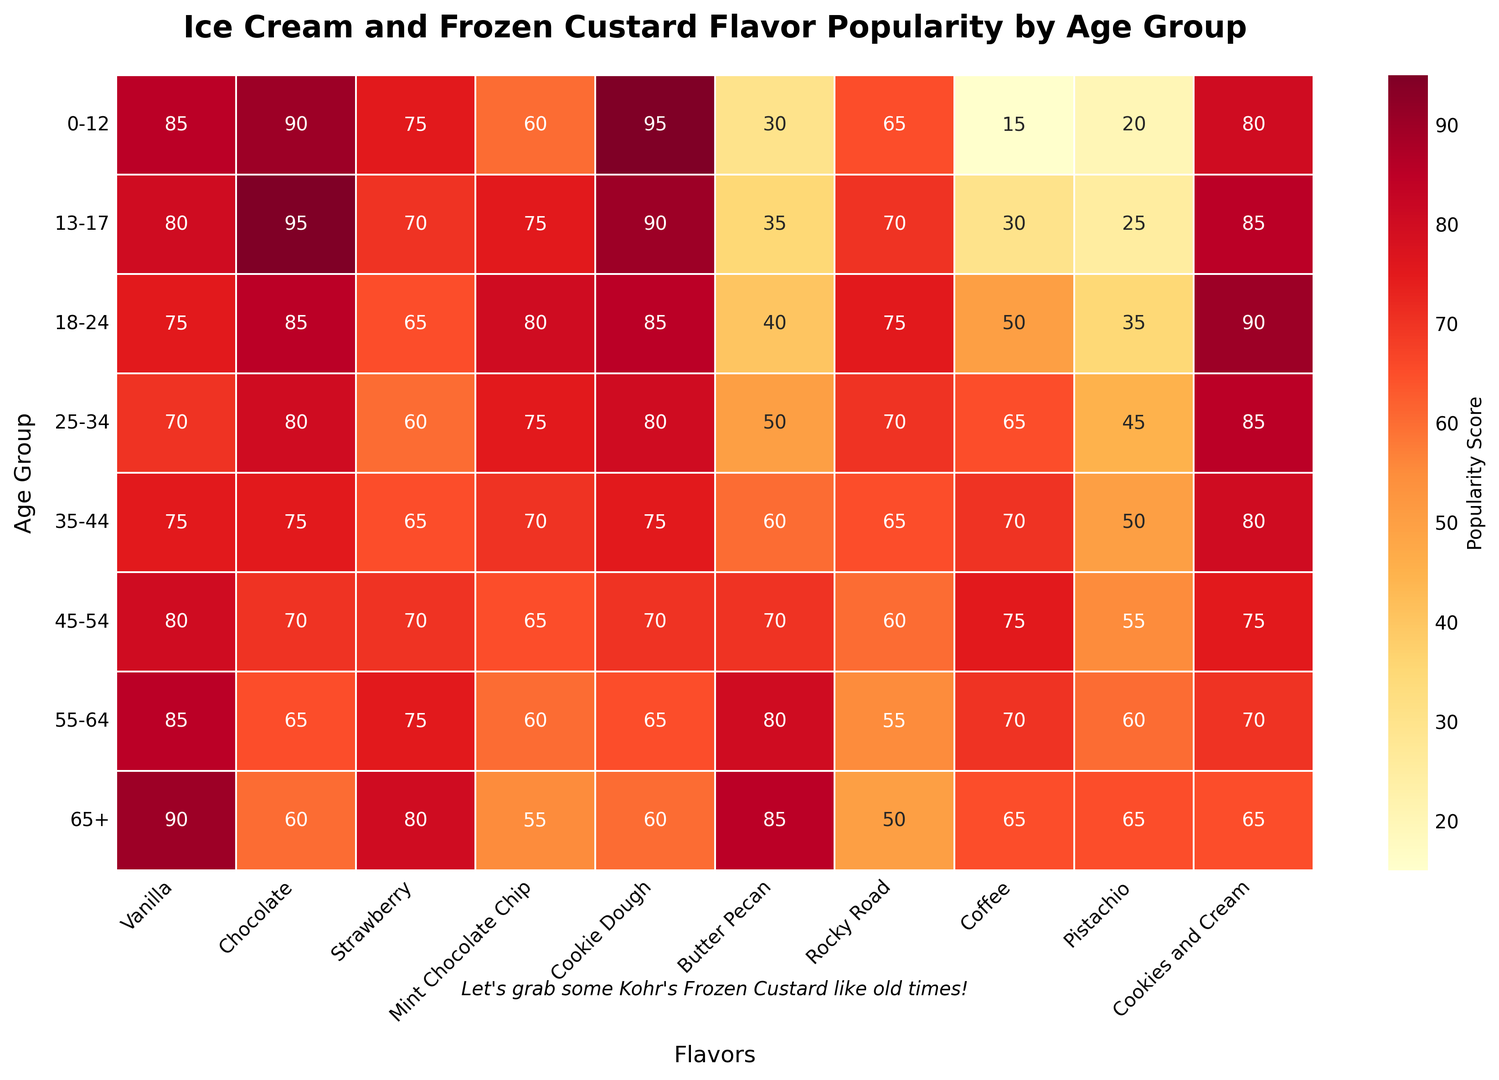Which age group has the highest popularity score for Vanilla? The colors in the heatmap and the annotations show the scores. The age group 65+ has the highest score of 90 for Vanilla.
Answer: 65+ Which flavor is most popular among teenagers aged 13-17? The flavor with the highest score for the age group 13-17 is Chocolate with a score of 95.
Answer: Chocolate Between ages 25-34 and 45-54, which age group prefers Coffee more? Comparing the scores for Coffee in the heatmap, the age group 45-54 has a higher score (75) than the 25-34 age group (65).
Answer: 45-54 What is the overall average popularity score for Butter Pecan across all age groups? Sum the scores for Butter Pecan across all age groups (30 + 35 + 40 + 50 + 60 + 70 + 80 + 85 = 450), then divide by the number of age groups (450 / 8 = 56.25).
Answer: 56.25 Which flavor has the lowest popularity score among children aged 0-12? The color with the lowest intensity in the 0-12 age group row indicates the lowest score which is for Coffee (15).
Answer: Coffee Comparing Vanilla and Mint Chocolate Chip, which flavor shows more consistent popularity across age groups? Vanilla shows less variation in scores (ranging from 70 to 90) compared to Mint Chocolate Chip (ranging from 55 to 80), indicating higher consistency.
Answer: Vanilla What is the difference in popularity scores for Cookies and Cream between ages 0-12 and 65+? The score for Cookies and Cream is 80 for the age group 0-12 and 65 for 65+. The difference is 80 - 65 = 15.
Answer: 15 Which flavor shows a decrease in popularity as the age groups increase? By looking at the rows and columns, Chocolate shows a slight, mostly decreasing trend as the age group increases.
Answer: Chocolate What is the combined popularity score of Pistachio for ages 0-12 and 13-17? Add up the scores for Pistachio for the age groups 0-12 and 13-17 (20 + 25 = 45).
Answer: 45 